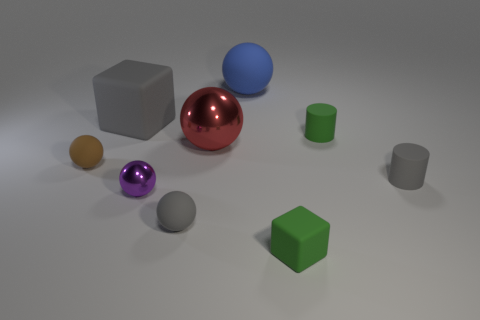Subtract all blue spheres. How many spheres are left? 4 Subtract all small metal balls. How many balls are left? 4 Subtract all green spheres. Subtract all red blocks. How many spheres are left? 5 Add 1 small shiny balls. How many objects exist? 10 Subtract all cylinders. How many objects are left? 7 Add 7 red metallic spheres. How many red metallic spheres exist? 8 Subtract 1 gray balls. How many objects are left? 8 Subtract all big red metal spheres. Subtract all tiny matte cubes. How many objects are left? 7 Add 9 brown rubber objects. How many brown rubber objects are left? 10 